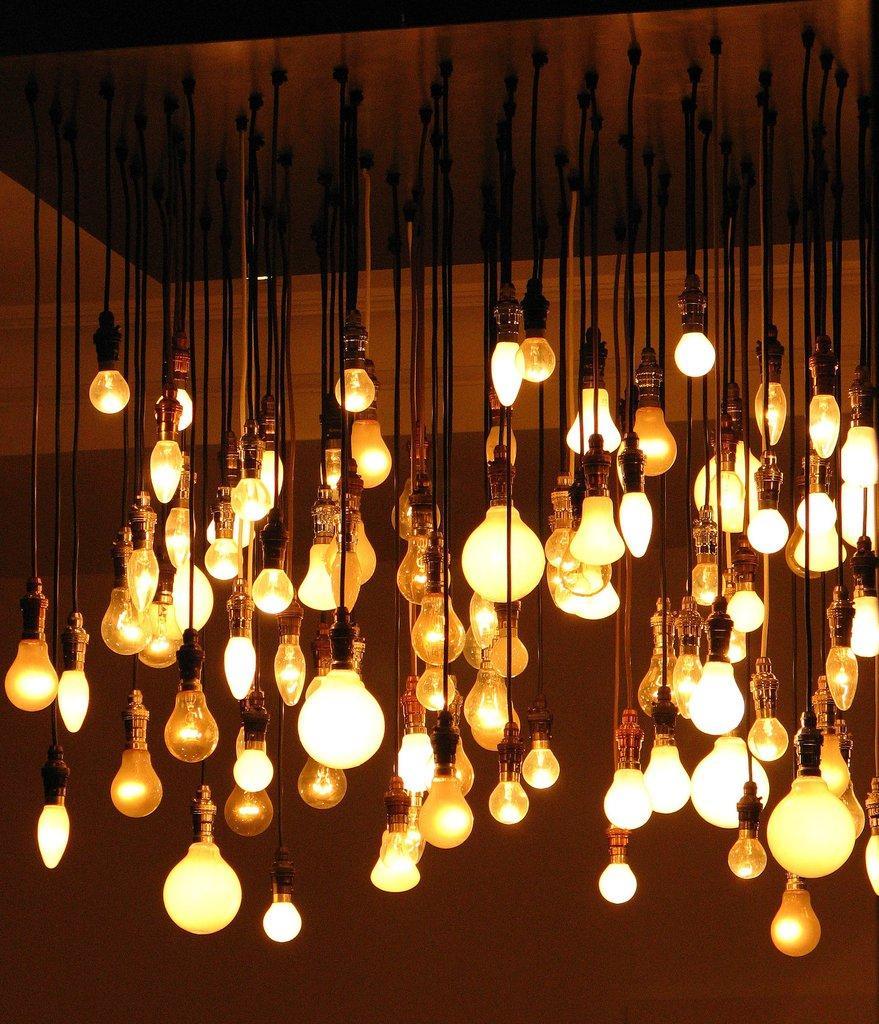In one or two sentences, can you explain what this image depicts? There are light bulbs which are hanging from the roof in the center of the image. 